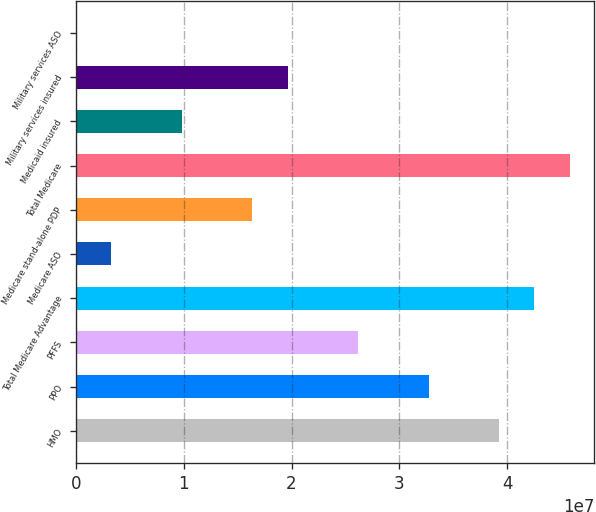Convert chart to OTSL. <chart><loc_0><loc_0><loc_500><loc_500><bar_chart><fcel>HMO<fcel>PPO<fcel>PFFS<fcel>Total Medicare Advantage<fcel>Medicare ASO<fcel>Medicare stand-alone PDP<fcel>Total Medicare<fcel>Medicaid insured<fcel>Military services insured<fcel>Military services ASO<nl><fcel>3.92548e+07<fcel>3.27123e+07<fcel>2.61699e+07<fcel>4.2526e+07<fcel>3.27123e+06<fcel>1.63562e+07<fcel>4.57973e+07<fcel>9.8137e+06<fcel>1.96274e+07<fcel>0.58<nl></chart> 